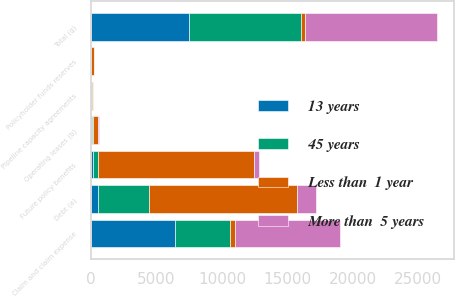Convert chart. <chart><loc_0><loc_0><loc_500><loc_500><stacked_bar_chart><ecel><fcel>Debt (a)<fcel>Operating leases (b)<fcel>Claim and claim expense<fcel>Future policy benefits<fcel>Policyholder funds reserves<fcel>Pipeline capacity agreements<fcel>Total (g)<nl><fcel>Less than  1 year<fcel>11340<fcel>340<fcel>333.5<fcel>11956<fcel>207<fcel>103<fcel>333.5<nl><fcel>13 years<fcel>499<fcel>93<fcel>6425<fcel>176<fcel>24<fcel>13<fcel>7509<nl><fcel>More than  5 years<fcel>1425<fcel>113<fcel>8087<fcel>342<fcel>10<fcel>22<fcel>10052<nl><fcel>45 years<fcel>3904<fcel>77<fcel>4210<fcel>327<fcel>4<fcel>21<fcel>8544<nl></chart> 